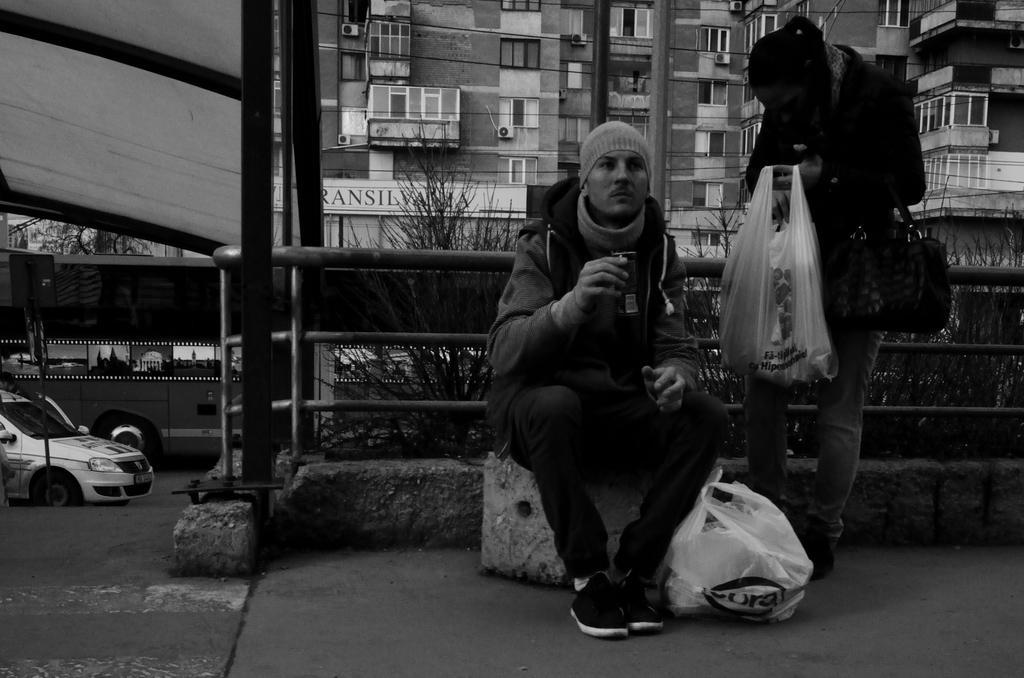In one or two sentences, can you explain what this image depicts? In the picture I can see two people among them one person is sitting and holding some object in the hand and other person is standing and holding a carry bag in hands. In the background I can see buildings, vehicles, plants, fence and some other objects. This picture is black and white in color. 